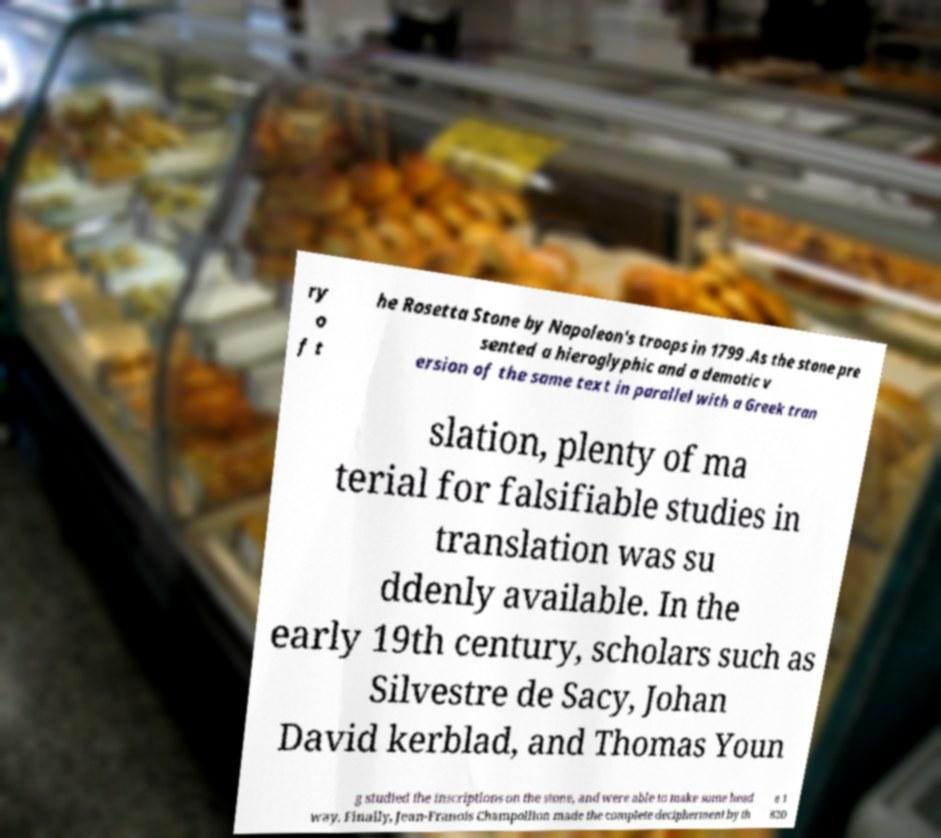What messages or text are displayed in this image? I need them in a readable, typed format. ry o f t he Rosetta Stone by Napoleon's troops in 1799 .As the stone pre sented a hieroglyphic and a demotic v ersion of the same text in parallel with a Greek tran slation, plenty of ma terial for falsifiable studies in translation was su ddenly available. In the early 19th century, scholars such as Silvestre de Sacy, Johan David kerblad, and Thomas Youn g studied the inscriptions on the stone, and were able to make some head way. Finally, Jean-Franois Champollion made the complete decipherment by th e 1 820 